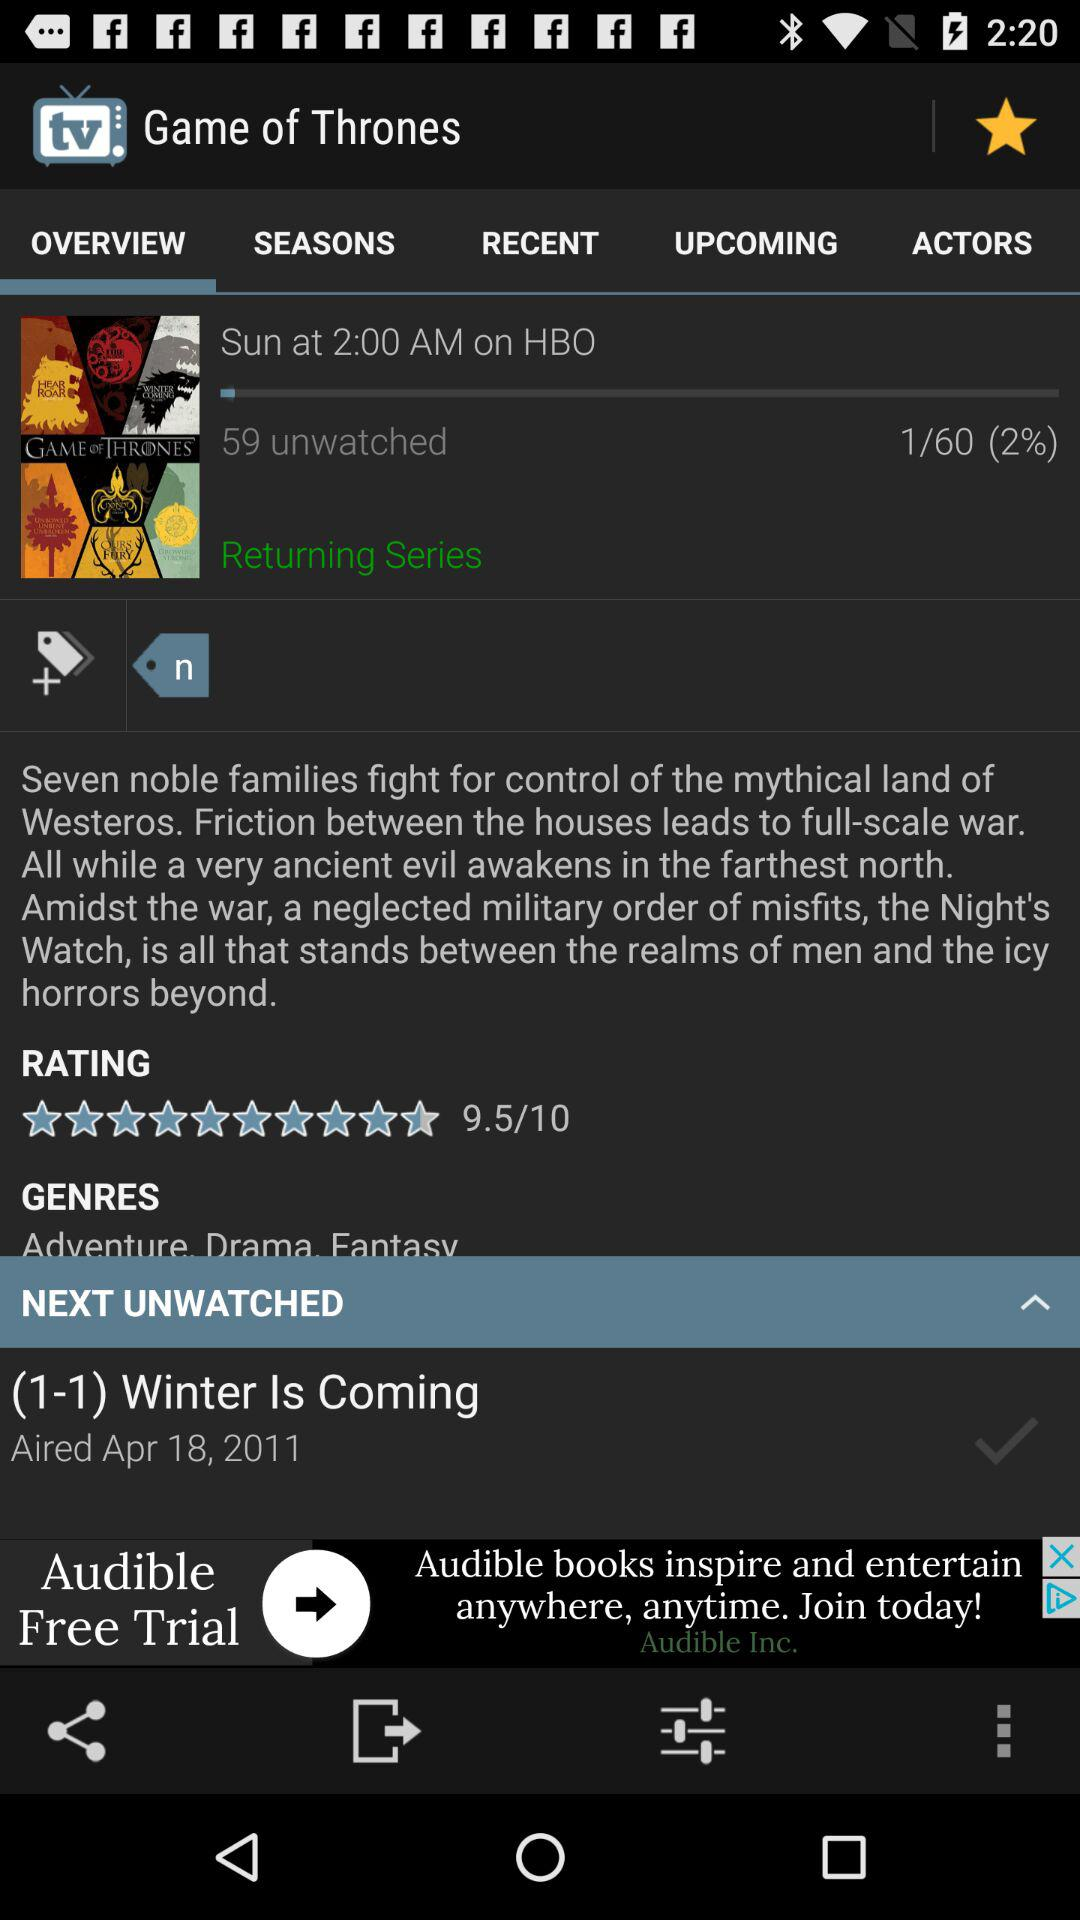Which tab has been selected? The tab "OVERVIEW" has been selected. 